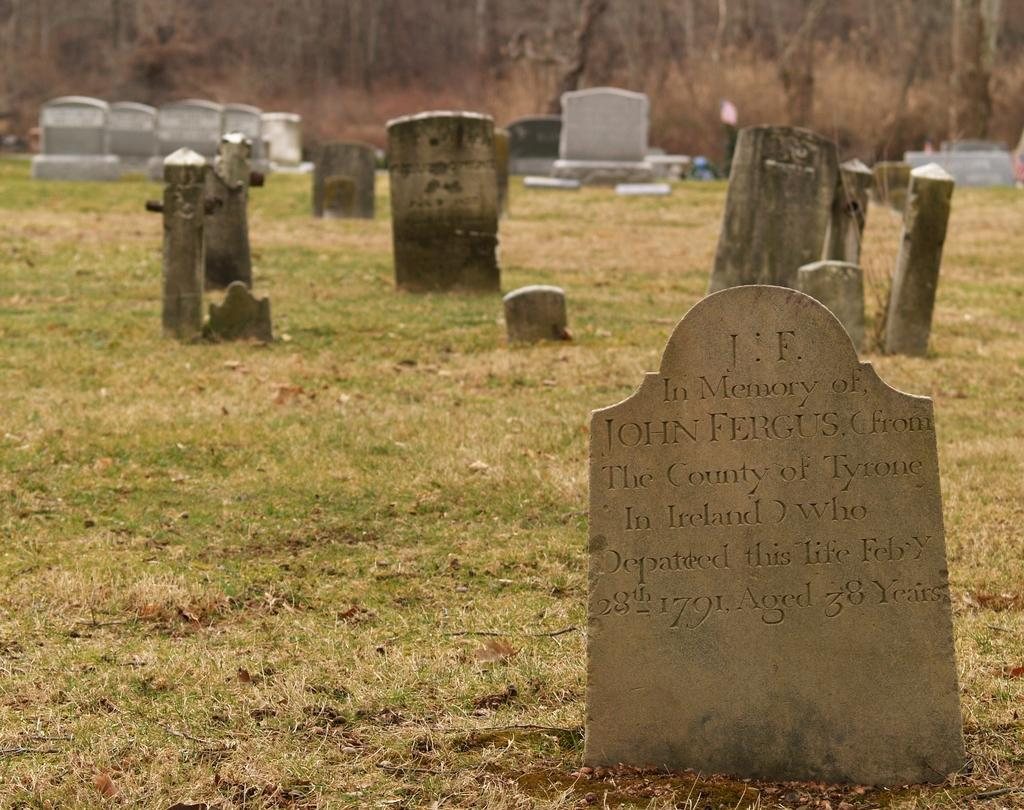What can be seen on the ground in the image? There are graves on the ground. What is covering the graves? Grass is present on the graves. What can be seen in the background of the image? There are trees in the background of the image. Where is the tub located in the image? There is no tub present in the image. What type of pot can be seen near the trees in the image? There is no pot present near the trees in the image. 